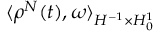Convert formula to latex. <formula><loc_0><loc_0><loc_500><loc_500>\langle \rho ^ { N } ( t ) , \omega \rangle _ { H ^ { - 1 } \times H _ { 0 } ^ { 1 } }</formula> 